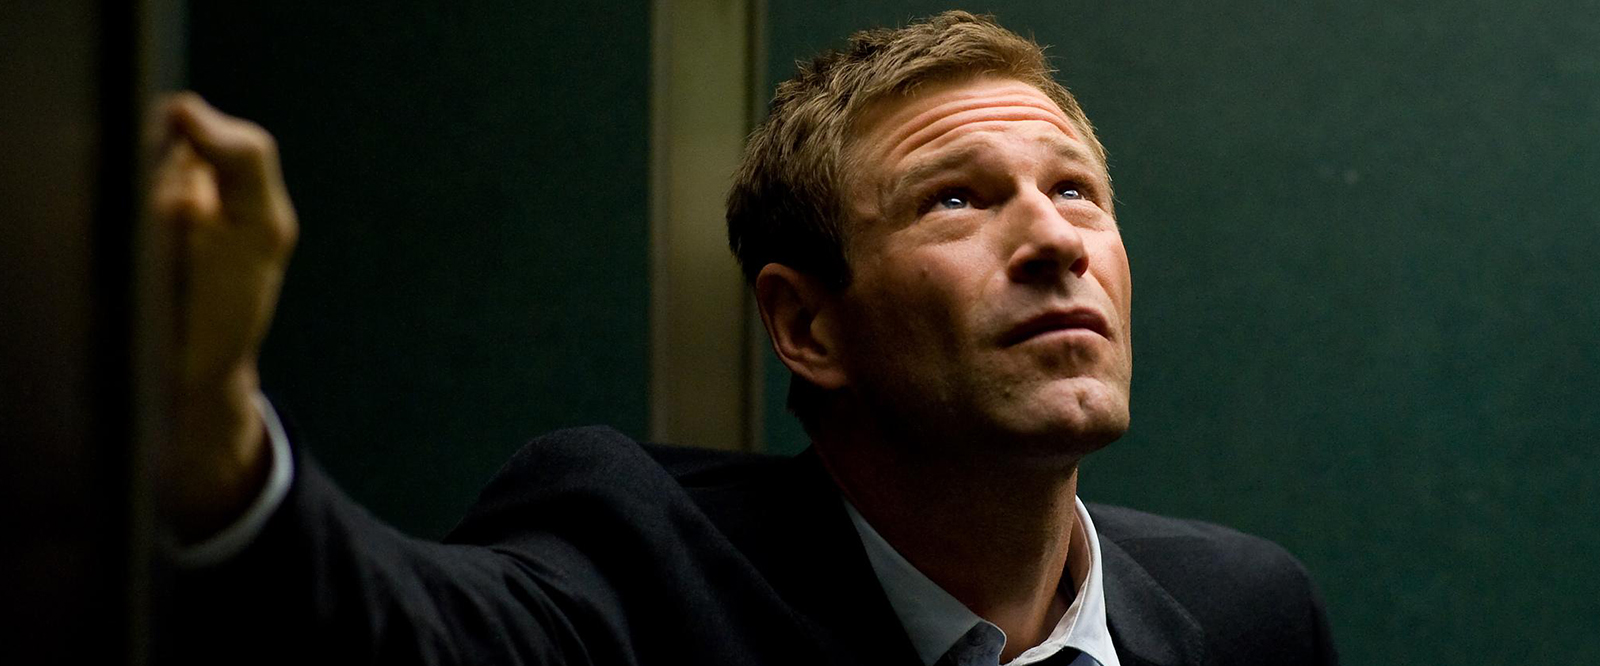What are the key elements in this picture? The image depicts a man in a dark suit standing in an indoor setting with a dimly lit green wall. He is partially leaning against the wall with one hand, while the other hand grips a railing, suggesting he is on a staircase or balcony. His upward gaze and deeply concerned expression might indicate he is engrossed in thought or looking at something alarming. This evokes a mood of tension and anticipation, common in dramatic or thriller scenes in films. 